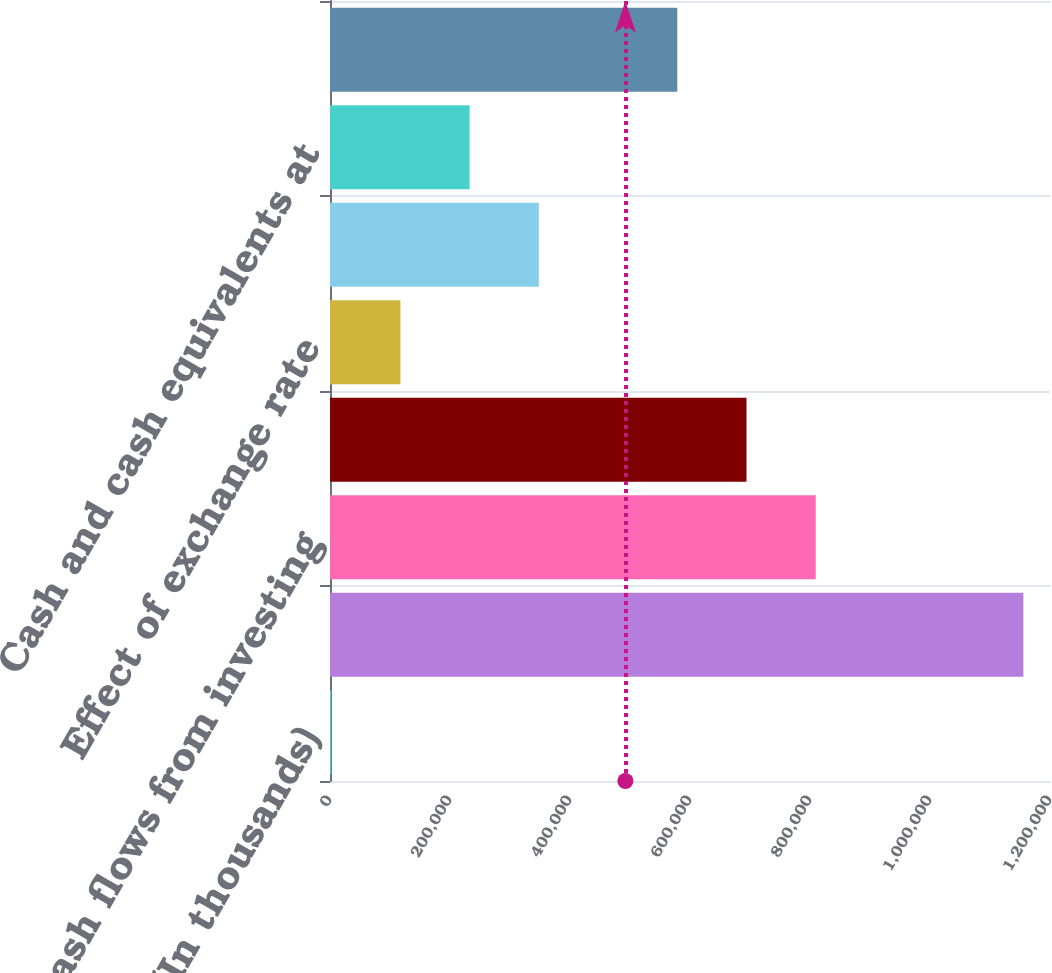<chart> <loc_0><loc_0><loc_500><loc_500><bar_chart><fcel>(In thousands)<fcel>Cash flows from operating<fcel>Cash flows from investing<fcel>Cash flows from financing<fcel>Effect of exchange rate<fcel>Total change in cash and cash<fcel>Cash and cash equivalents at<fcel>Free cash flow (non-GAAP)<nl><fcel>2016<fcel>1.15561e+06<fcel>809533<fcel>694174<fcel>117376<fcel>348095<fcel>232735<fcel>578814<nl></chart> 